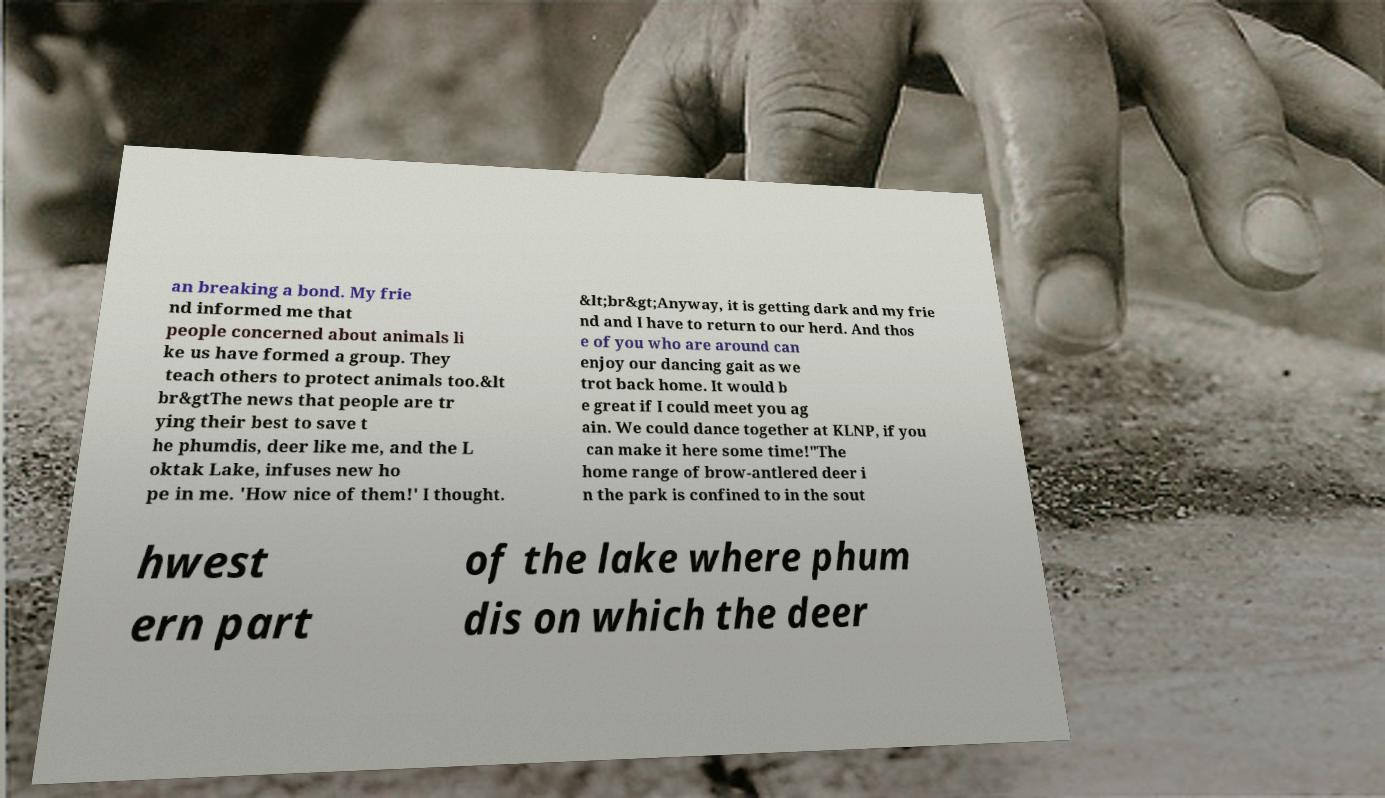Please identify and transcribe the text found in this image. an breaking a bond. My frie nd informed me that people concerned about animals li ke us have formed a group. They teach others to protect animals too.&lt br&gtThe news that people are tr ying their best to save t he phumdis, deer like me, and the L oktak Lake, infuses new ho pe in me. 'How nice of them!' I thought. &lt;br&gt;Anyway, it is getting dark and my frie nd and I have to return to our herd. And thos e of you who are around can enjoy our dancing gait as we trot back home. It would b e great if I could meet you ag ain. We could dance together at KLNP, if you can make it here some time!"The home range of brow-antlered deer i n the park is confined to in the sout hwest ern part of the lake where phum dis on which the deer 